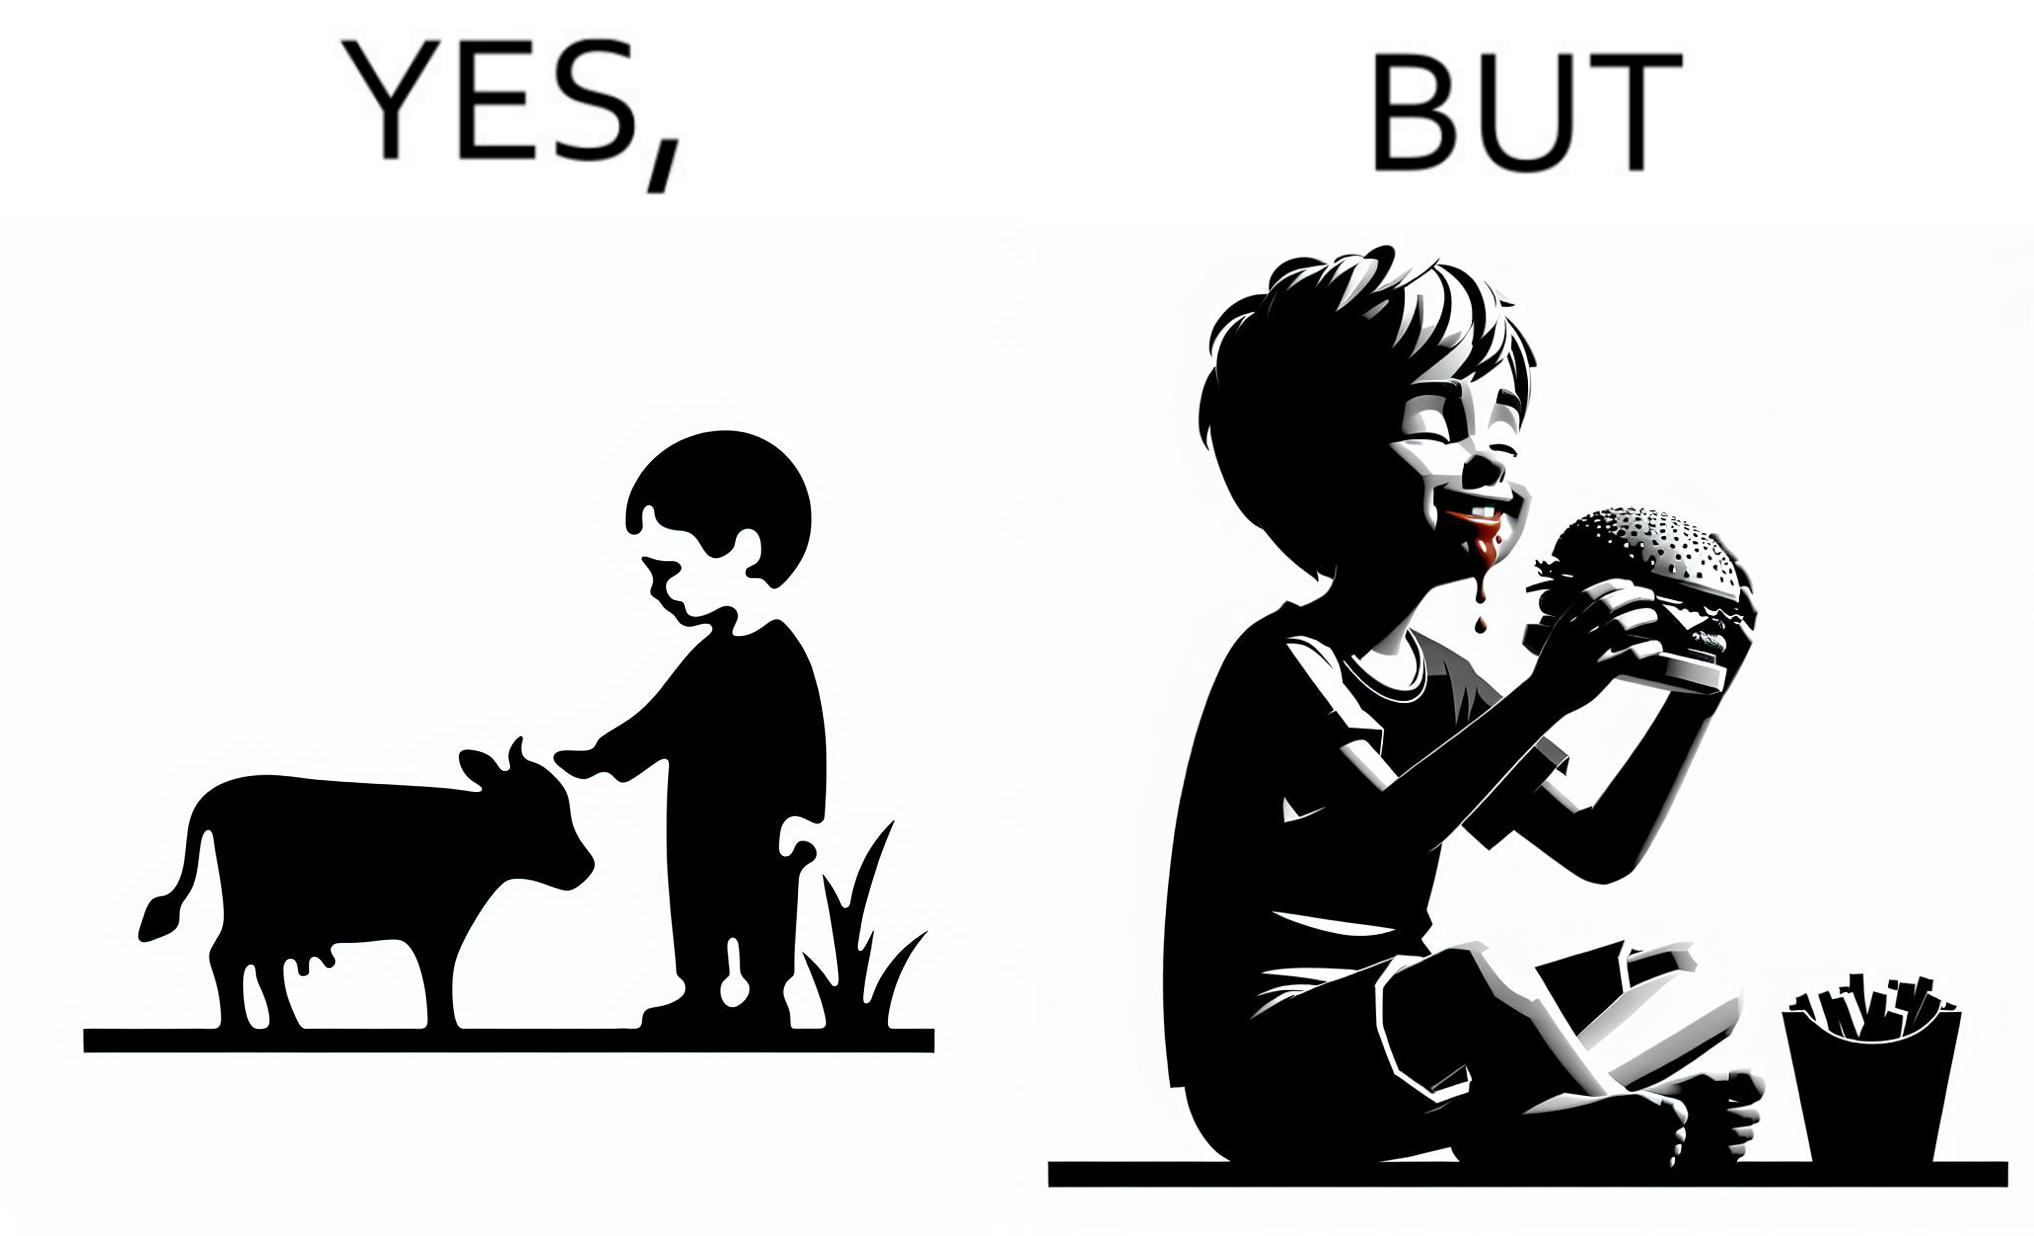Describe what you see in the left and right parts of this image. In the left part of the image: A boy petting a cow In the right part of the image: A boy eating a hamburger 